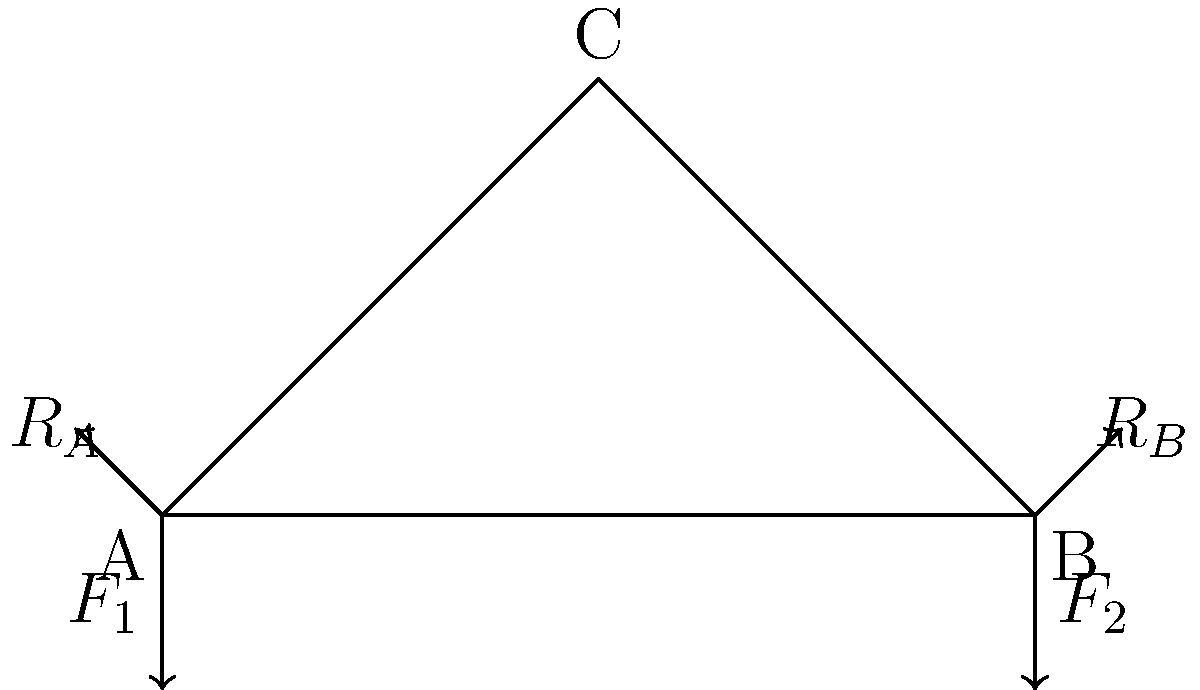Given the simple truss design shown in the force diagram, calculate the magnitude of the reaction force $R_A$ if $F_1 = 10$ kN, $F_2 = 15$ kN, and the angle at point C is 60°. How does this compare to the efficiency of a similar truss with a 45° angle at point C? To solve this problem and compare efficiencies, we'll follow these steps:

1) First, let's calculate $R_A$ for the given 60° truss:

   a) The sum of vertical forces must equal zero:
      $R_A + R_B - F_1 - F_2 = 0$

   b) The sum of moments about point B must equal zero:
      $R_A \cdot 100 - F_1 \cdot 100 = 0$

   c) From (b), we can find $R_A$:
      $R_A = F_1 = 10$ kN

   d) From (a), we can now find $R_B$:
      $R_B = F_1 + F_2 - R_A = 10 + 15 - 10 = 15$ kN

2) Now, let's consider a 45° truss:

   a) The height of the truss would change, affecting the moment arm of $F_1$.
   b) The new moment equation would be:
      $R_A \cdot 100 - F_1 \cdot 50 = 0$

   c) Solving for $R_A$:
      $R_A = \frac{F_1 \cdot 50}{100} = 5$ kN

3) Comparing efficiencies:

   a) In structural engineering, efficiency often relates to material usage and load distribution.
   b) The 60° truss has higher reaction forces ($R_A = 10$ kN, $R_B = 15$ kN) compared to the 45° truss ($R_A = 5$ kN, $R_B = 20$ kN).
   c) The 45° truss distributes the load more evenly between its members, potentially allowing for more efficient material use.
   d) However, the 60° truss is taller, which could provide better stability in some scenarios.

4) Conclusion:
   The 45° truss is generally more efficient in terms of load distribution and potentially material usage, but the optimal choice depends on specific project requirements and constraints.
Answer: $R_A = 10$ kN for 60° truss; 45° truss is more efficient in load distribution. 